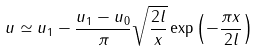Convert formula to latex. <formula><loc_0><loc_0><loc_500><loc_500>u \simeq u _ { 1 } - \frac { u _ { 1 } - u _ { 0 } } { \pi } \sqrt { \frac { 2 l } { x } } \exp \left ( - \frac { \pi x } { 2 l } \right )</formula> 